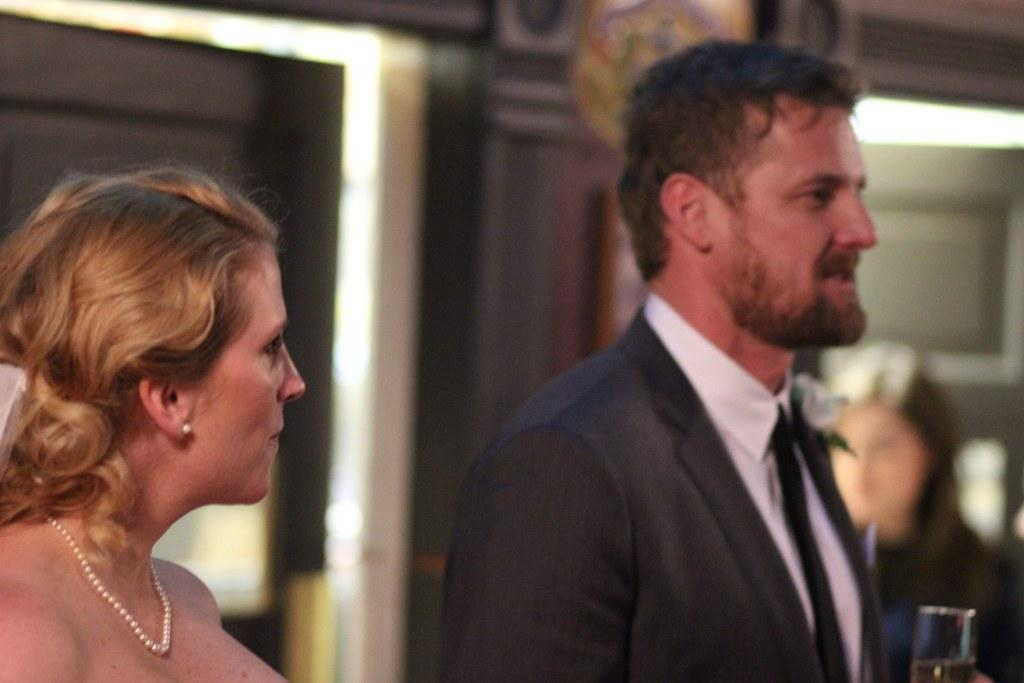What is the main subject of the image? There is a man in the image. What is the man holding in his hand? The man is holding a glass in his hand. Is there anyone else in the image besides the man? Yes, there is a woman standing beside the man. Can you describe the background of the image? The background of the image is blurred. What type of bells can be heard ringing in the image? There are no bells present in the image, and therefore no sound can be heard. 